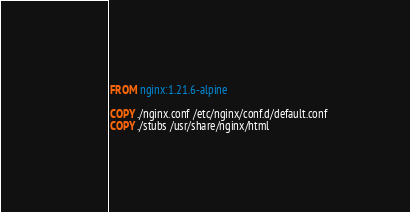<code> <loc_0><loc_0><loc_500><loc_500><_Dockerfile_>FROM nginx:1.21.6-alpine

COPY ./nginx.conf /etc/nginx/conf.d/default.conf
COPY ./stubs /usr/share/nginx/html
</code> 